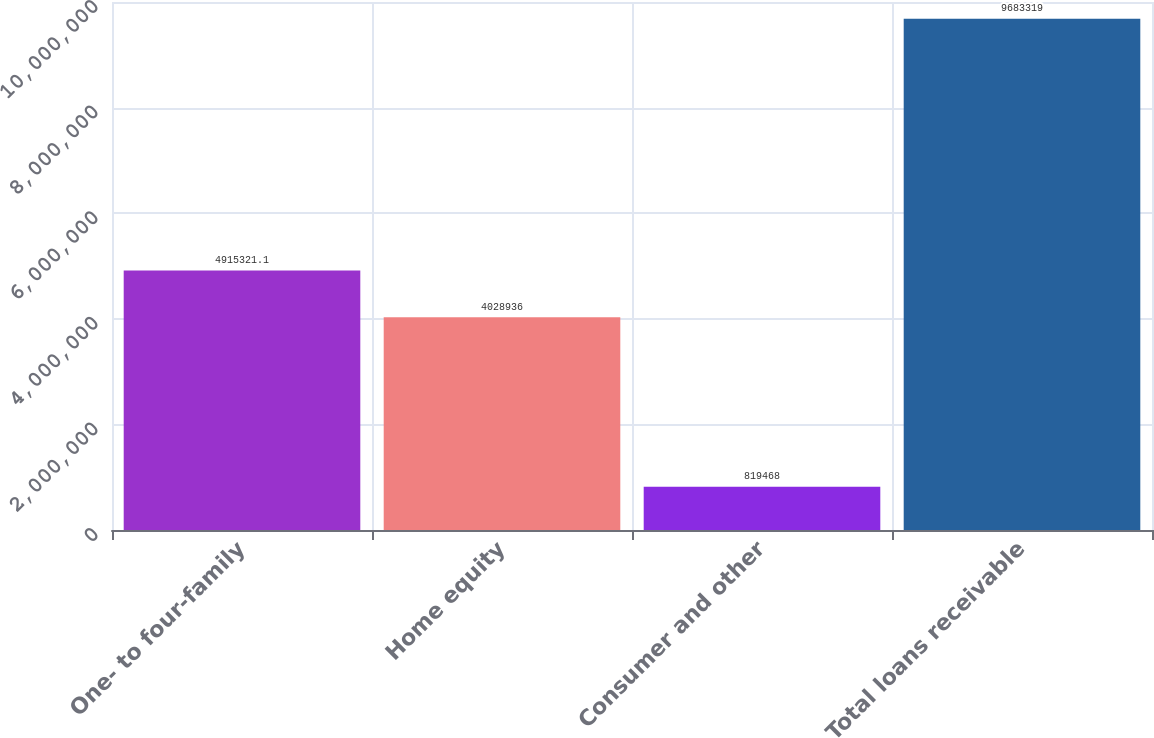Convert chart to OTSL. <chart><loc_0><loc_0><loc_500><loc_500><bar_chart><fcel>One- to four-family<fcel>Home equity<fcel>Consumer and other<fcel>Total loans receivable<nl><fcel>4.91532e+06<fcel>4.02894e+06<fcel>819468<fcel>9.68332e+06<nl></chart> 